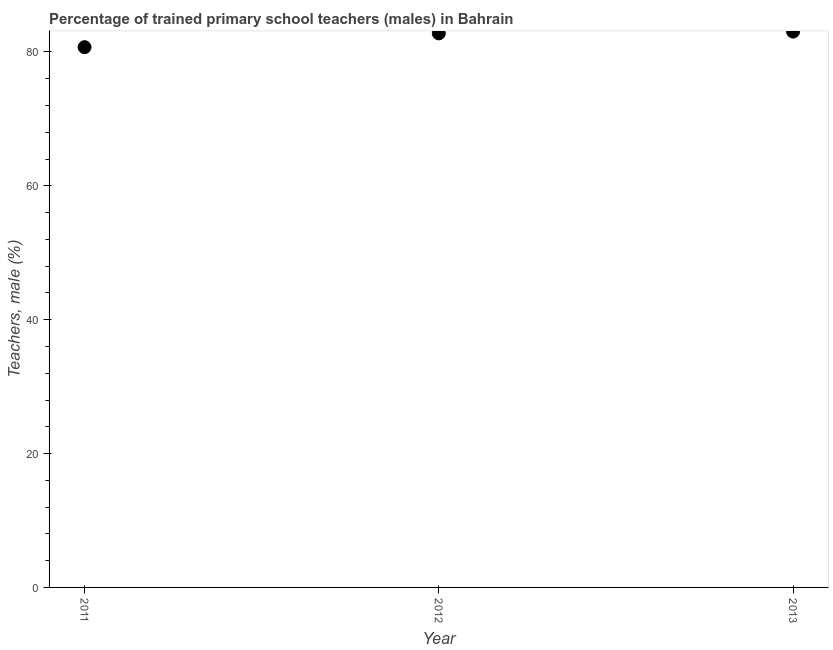What is the percentage of trained male teachers in 2011?
Make the answer very short. 80.72. Across all years, what is the maximum percentage of trained male teachers?
Ensure brevity in your answer.  83.04. Across all years, what is the minimum percentage of trained male teachers?
Make the answer very short. 80.72. In which year was the percentage of trained male teachers maximum?
Make the answer very short. 2013. In which year was the percentage of trained male teachers minimum?
Give a very brief answer. 2011. What is the sum of the percentage of trained male teachers?
Your answer should be very brief. 246.54. What is the difference between the percentage of trained male teachers in 2012 and 2013?
Make the answer very short. -0.27. What is the average percentage of trained male teachers per year?
Provide a short and direct response. 82.18. What is the median percentage of trained male teachers?
Your response must be concise. 82.78. In how many years, is the percentage of trained male teachers greater than 28 %?
Offer a very short reply. 3. Do a majority of the years between 2013 and 2012 (inclusive) have percentage of trained male teachers greater than 4 %?
Give a very brief answer. No. What is the ratio of the percentage of trained male teachers in 2012 to that in 2013?
Your response must be concise. 1. What is the difference between the highest and the second highest percentage of trained male teachers?
Your answer should be very brief. 0.27. Is the sum of the percentage of trained male teachers in 2011 and 2013 greater than the maximum percentage of trained male teachers across all years?
Your response must be concise. Yes. What is the difference between the highest and the lowest percentage of trained male teachers?
Your response must be concise. 2.32. How many dotlines are there?
Your response must be concise. 1. What is the difference between two consecutive major ticks on the Y-axis?
Give a very brief answer. 20. Are the values on the major ticks of Y-axis written in scientific E-notation?
Give a very brief answer. No. Does the graph contain grids?
Give a very brief answer. No. What is the title of the graph?
Provide a succinct answer. Percentage of trained primary school teachers (males) in Bahrain. What is the label or title of the X-axis?
Provide a short and direct response. Year. What is the label or title of the Y-axis?
Provide a succinct answer. Teachers, male (%). What is the Teachers, male (%) in 2011?
Offer a terse response. 80.72. What is the Teachers, male (%) in 2012?
Give a very brief answer. 82.78. What is the Teachers, male (%) in 2013?
Give a very brief answer. 83.04. What is the difference between the Teachers, male (%) in 2011 and 2012?
Provide a short and direct response. -2.06. What is the difference between the Teachers, male (%) in 2011 and 2013?
Make the answer very short. -2.32. What is the difference between the Teachers, male (%) in 2012 and 2013?
Keep it short and to the point. -0.27. What is the ratio of the Teachers, male (%) in 2012 to that in 2013?
Your answer should be very brief. 1. 